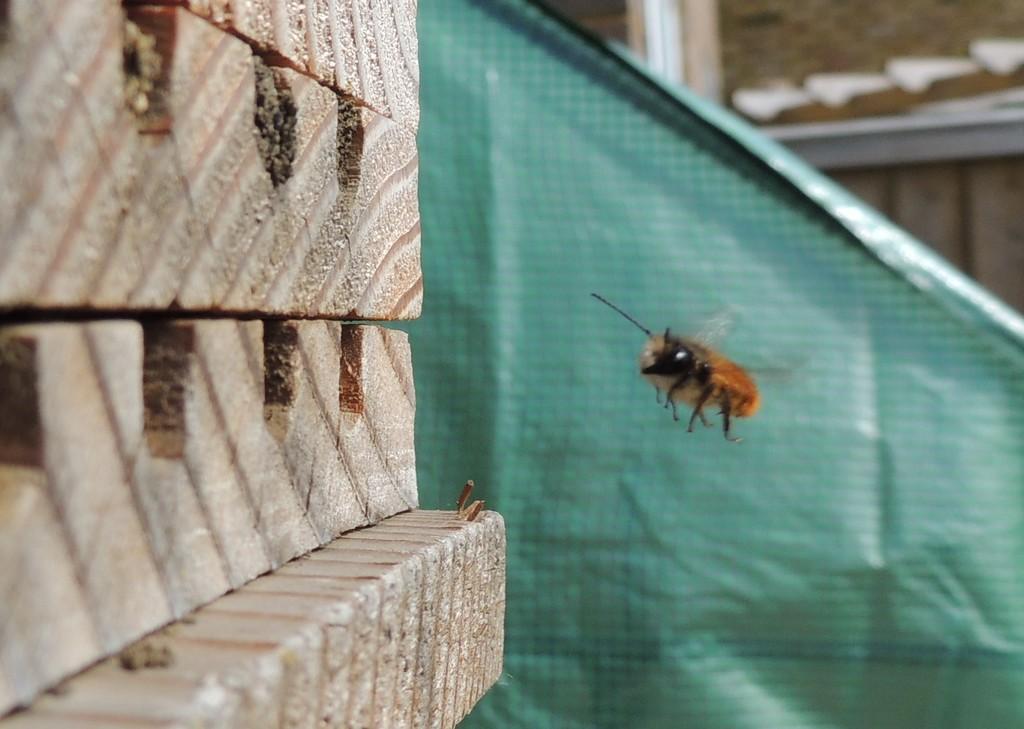Could you give a brief overview of what you see in this image? In this image in the middle, there is an insect flying. On the left there are bricks. In the background there is a sheet and house. 